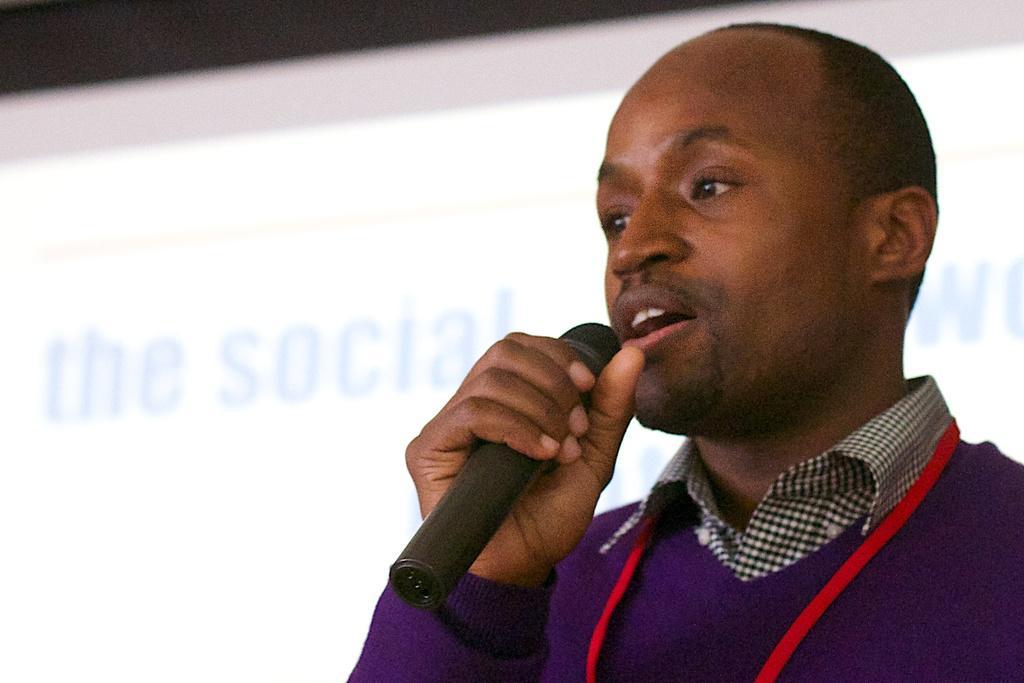Could you give a brief overview of what you see in this image? In this image, we can see a person is holding a microphone and talking. Background we can see the screen. 